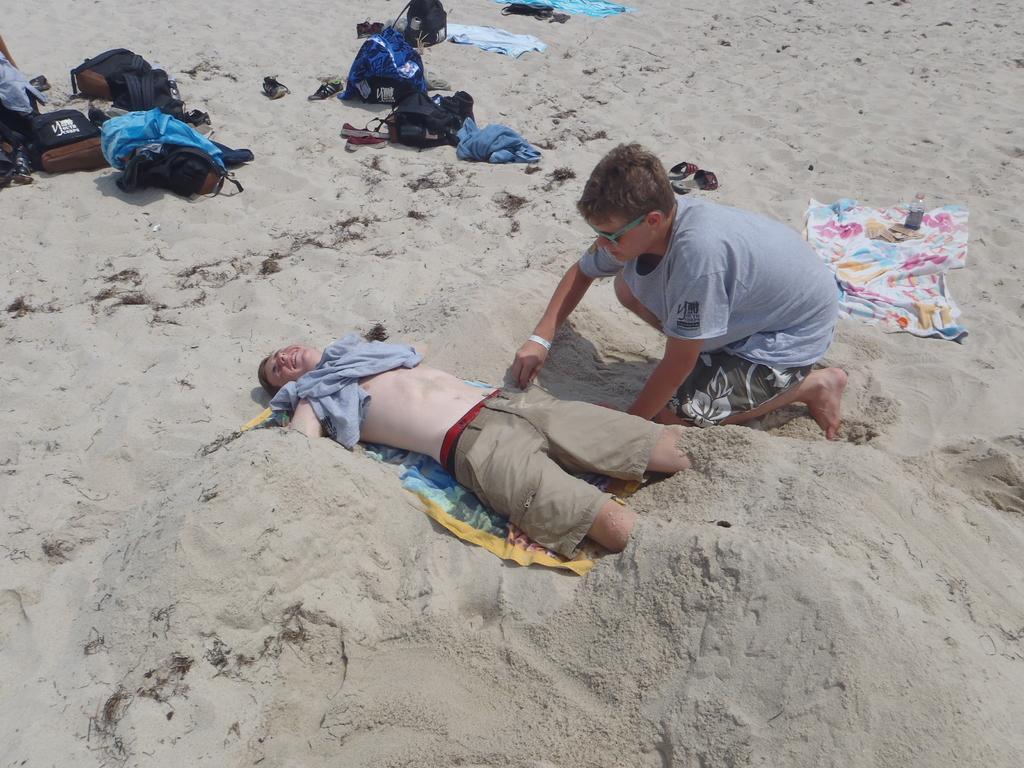In one or two sentences, can you explain what this image depicts? In this picture I can see a person lying in the sand. I can see a boy on the right side. I can see the bags and clothes. 